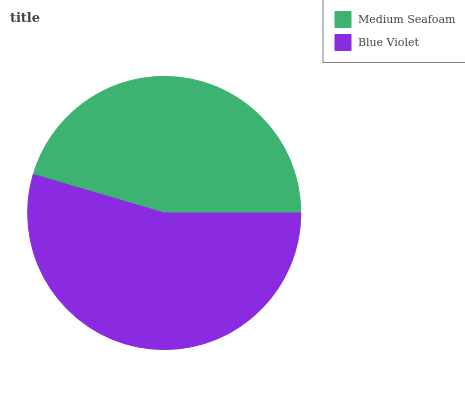Is Medium Seafoam the minimum?
Answer yes or no. Yes. Is Blue Violet the maximum?
Answer yes or no. Yes. Is Blue Violet the minimum?
Answer yes or no. No. Is Blue Violet greater than Medium Seafoam?
Answer yes or no. Yes. Is Medium Seafoam less than Blue Violet?
Answer yes or no. Yes. Is Medium Seafoam greater than Blue Violet?
Answer yes or no. No. Is Blue Violet less than Medium Seafoam?
Answer yes or no. No. Is Blue Violet the high median?
Answer yes or no. Yes. Is Medium Seafoam the low median?
Answer yes or no. Yes. Is Medium Seafoam the high median?
Answer yes or no. No. Is Blue Violet the low median?
Answer yes or no. No. 